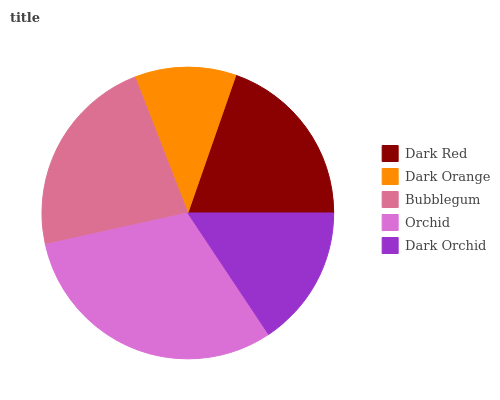Is Dark Orange the minimum?
Answer yes or no. Yes. Is Orchid the maximum?
Answer yes or no. Yes. Is Bubblegum the minimum?
Answer yes or no. No. Is Bubblegum the maximum?
Answer yes or no. No. Is Bubblegum greater than Dark Orange?
Answer yes or no. Yes. Is Dark Orange less than Bubblegum?
Answer yes or no. Yes. Is Dark Orange greater than Bubblegum?
Answer yes or no. No. Is Bubblegum less than Dark Orange?
Answer yes or no. No. Is Dark Red the high median?
Answer yes or no. Yes. Is Dark Red the low median?
Answer yes or no. Yes. Is Bubblegum the high median?
Answer yes or no. No. Is Bubblegum the low median?
Answer yes or no. No. 